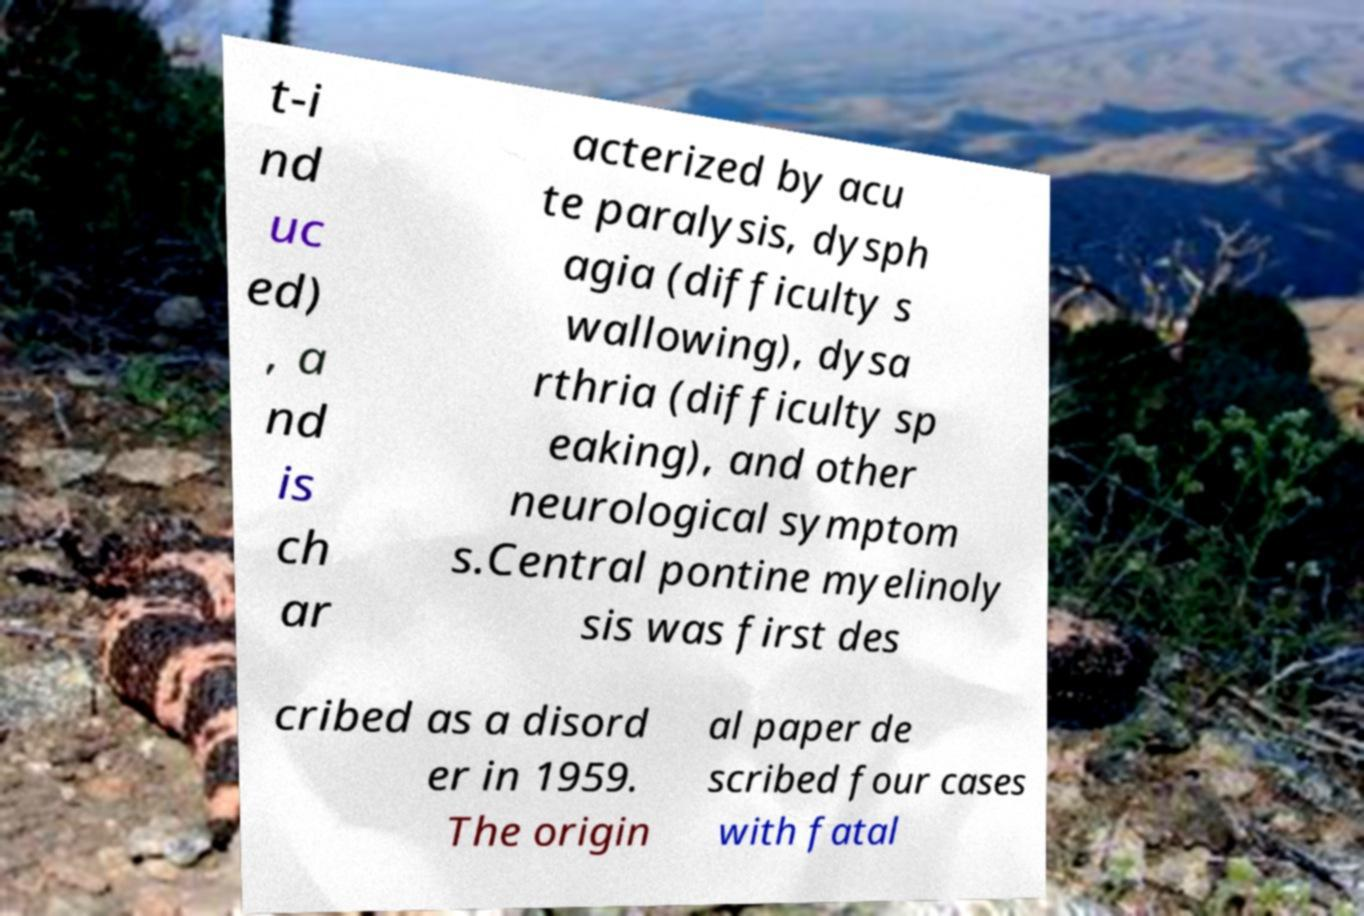I need the written content from this picture converted into text. Can you do that? t-i nd uc ed) , a nd is ch ar acterized by acu te paralysis, dysph agia (difficulty s wallowing), dysa rthria (difficulty sp eaking), and other neurological symptom s.Central pontine myelinoly sis was first des cribed as a disord er in 1959. The origin al paper de scribed four cases with fatal 